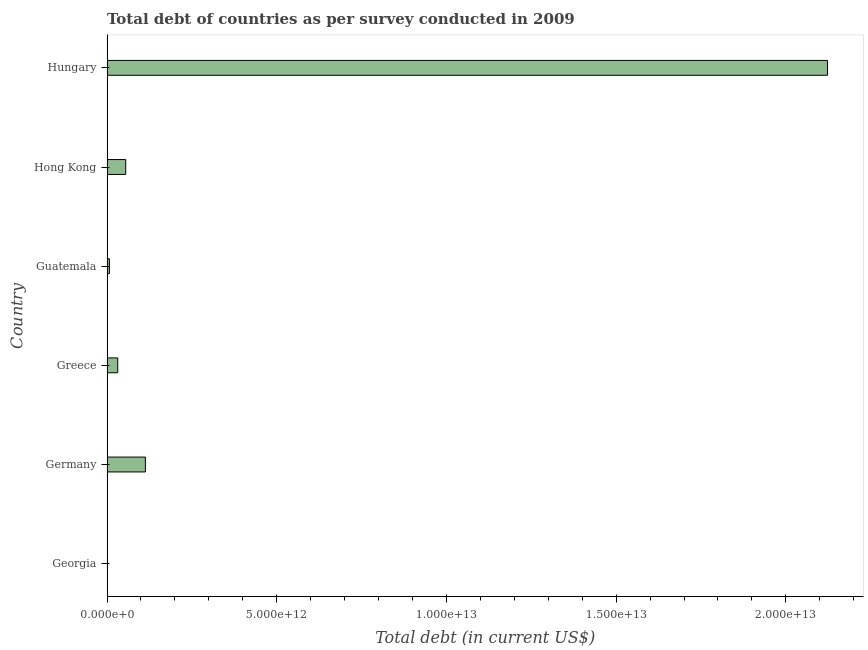What is the title of the graph?
Offer a terse response. Total debt of countries as per survey conducted in 2009. What is the label or title of the X-axis?
Offer a very short reply. Total debt (in current US$). What is the label or title of the Y-axis?
Give a very brief answer. Country. What is the total debt in Georgia?
Your answer should be compact. 6.23e+09. Across all countries, what is the maximum total debt?
Offer a very short reply. 2.12e+13. Across all countries, what is the minimum total debt?
Provide a succinct answer. 6.23e+09. In which country was the total debt maximum?
Make the answer very short. Hungary. In which country was the total debt minimum?
Keep it short and to the point. Georgia. What is the sum of the total debt?
Offer a very short reply. 2.33e+13. What is the difference between the total debt in Germany and Hong Kong?
Provide a short and direct response. 5.80e+11. What is the average total debt per country?
Offer a very short reply. 3.88e+12. What is the median total debt?
Your response must be concise. 4.34e+11. In how many countries, is the total debt greater than 18000000000000 US$?
Ensure brevity in your answer.  1. What is the ratio of the total debt in Georgia to that in Hungary?
Offer a very short reply. 0. What is the difference between the highest and the second highest total debt?
Offer a terse response. 2.01e+13. What is the difference between the highest and the lowest total debt?
Provide a succinct answer. 2.12e+13. Are all the bars in the graph horizontal?
Make the answer very short. Yes. What is the difference between two consecutive major ticks on the X-axis?
Offer a terse response. 5.00e+12. Are the values on the major ticks of X-axis written in scientific E-notation?
Give a very brief answer. Yes. What is the Total debt (in current US$) in Georgia?
Your response must be concise. 6.23e+09. What is the Total debt (in current US$) of Germany?
Keep it short and to the point. 1.13e+12. What is the Total debt (in current US$) in Greece?
Keep it short and to the point. 3.16e+11. What is the Total debt (in current US$) in Guatemala?
Ensure brevity in your answer.  7.09e+1. What is the Total debt (in current US$) of Hong Kong?
Offer a terse response. 5.51e+11. What is the Total debt (in current US$) in Hungary?
Your answer should be compact. 2.12e+13. What is the difference between the Total debt (in current US$) in Georgia and Germany?
Your answer should be very brief. -1.12e+12. What is the difference between the Total debt (in current US$) in Georgia and Greece?
Keep it short and to the point. -3.10e+11. What is the difference between the Total debt (in current US$) in Georgia and Guatemala?
Offer a terse response. -6.47e+1. What is the difference between the Total debt (in current US$) in Georgia and Hong Kong?
Ensure brevity in your answer.  -5.45e+11. What is the difference between the Total debt (in current US$) in Georgia and Hungary?
Your response must be concise. -2.12e+13. What is the difference between the Total debt (in current US$) in Germany and Greece?
Provide a short and direct response. 8.15e+11. What is the difference between the Total debt (in current US$) in Germany and Guatemala?
Offer a terse response. 1.06e+12. What is the difference between the Total debt (in current US$) in Germany and Hong Kong?
Your answer should be very brief. 5.80e+11. What is the difference between the Total debt (in current US$) in Germany and Hungary?
Keep it short and to the point. -2.01e+13. What is the difference between the Total debt (in current US$) in Greece and Guatemala?
Your response must be concise. 2.45e+11. What is the difference between the Total debt (in current US$) in Greece and Hong Kong?
Your answer should be very brief. -2.35e+11. What is the difference between the Total debt (in current US$) in Greece and Hungary?
Keep it short and to the point. -2.09e+13. What is the difference between the Total debt (in current US$) in Guatemala and Hong Kong?
Your response must be concise. -4.80e+11. What is the difference between the Total debt (in current US$) in Guatemala and Hungary?
Make the answer very short. -2.12e+13. What is the difference between the Total debt (in current US$) in Hong Kong and Hungary?
Ensure brevity in your answer.  -2.07e+13. What is the ratio of the Total debt (in current US$) in Georgia to that in Germany?
Your response must be concise. 0.01. What is the ratio of the Total debt (in current US$) in Georgia to that in Greece?
Offer a very short reply. 0.02. What is the ratio of the Total debt (in current US$) in Georgia to that in Guatemala?
Offer a very short reply. 0.09. What is the ratio of the Total debt (in current US$) in Georgia to that in Hong Kong?
Ensure brevity in your answer.  0.01. What is the ratio of the Total debt (in current US$) in Germany to that in Greece?
Provide a short and direct response. 3.58. What is the ratio of the Total debt (in current US$) in Germany to that in Guatemala?
Your answer should be compact. 15.96. What is the ratio of the Total debt (in current US$) in Germany to that in Hong Kong?
Offer a terse response. 2.05. What is the ratio of the Total debt (in current US$) in Germany to that in Hungary?
Provide a succinct answer. 0.05. What is the ratio of the Total debt (in current US$) in Greece to that in Guatemala?
Your answer should be compact. 4.46. What is the ratio of the Total debt (in current US$) in Greece to that in Hong Kong?
Provide a succinct answer. 0.57. What is the ratio of the Total debt (in current US$) in Greece to that in Hungary?
Give a very brief answer. 0.01. What is the ratio of the Total debt (in current US$) in Guatemala to that in Hong Kong?
Give a very brief answer. 0.13. What is the ratio of the Total debt (in current US$) in Guatemala to that in Hungary?
Provide a short and direct response. 0. What is the ratio of the Total debt (in current US$) in Hong Kong to that in Hungary?
Your answer should be compact. 0.03. 